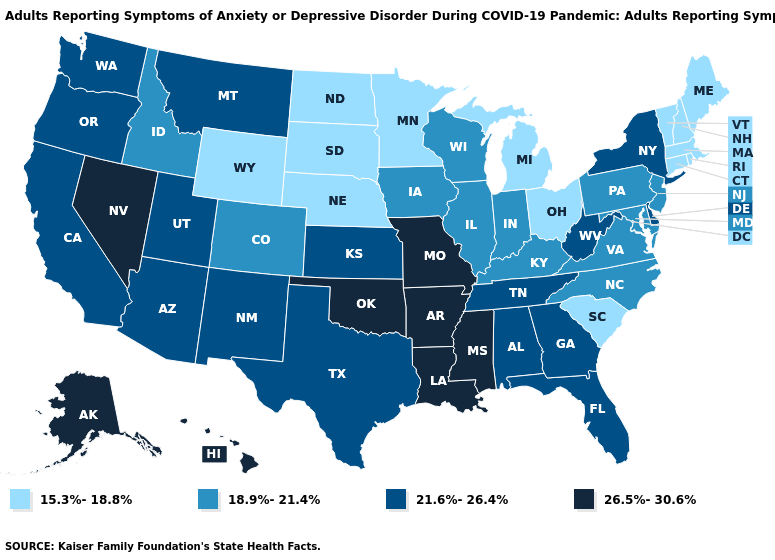Name the states that have a value in the range 21.6%-26.4%?
Be succinct. Alabama, Arizona, California, Delaware, Florida, Georgia, Kansas, Montana, New Mexico, New York, Oregon, Tennessee, Texas, Utah, Washington, West Virginia. Name the states that have a value in the range 15.3%-18.8%?
Answer briefly. Connecticut, Maine, Massachusetts, Michigan, Minnesota, Nebraska, New Hampshire, North Dakota, Ohio, Rhode Island, South Carolina, South Dakota, Vermont, Wyoming. Is the legend a continuous bar?
Give a very brief answer. No. What is the lowest value in states that border Texas?
Be succinct. 21.6%-26.4%. What is the value of Iowa?
Give a very brief answer. 18.9%-21.4%. Name the states that have a value in the range 15.3%-18.8%?
Concise answer only. Connecticut, Maine, Massachusetts, Michigan, Minnesota, Nebraska, New Hampshire, North Dakota, Ohio, Rhode Island, South Carolina, South Dakota, Vermont, Wyoming. Name the states that have a value in the range 18.9%-21.4%?
Give a very brief answer. Colorado, Idaho, Illinois, Indiana, Iowa, Kentucky, Maryland, New Jersey, North Carolina, Pennsylvania, Virginia, Wisconsin. Does Tennessee have the lowest value in the USA?
Give a very brief answer. No. What is the value of New Mexico?
Short answer required. 21.6%-26.4%. Among the states that border Alabama , which have the highest value?
Short answer required. Mississippi. What is the value of South Dakota?
Concise answer only. 15.3%-18.8%. Does Mississippi have the highest value in the South?
Quick response, please. Yes. Among the states that border West Virginia , does Virginia have the lowest value?
Be succinct. No. Name the states that have a value in the range 18.9%-21.4%?
Write a very short answer. Colorado, Idaho, Illinois, Indiana, Iowa, Kentucky, Maryland, New Jersey, North Carolina, Pennsylvania, Virginia, Wisconsin. What is the value of Tennessee?
Short answer required. 21.6%-26.4%. 